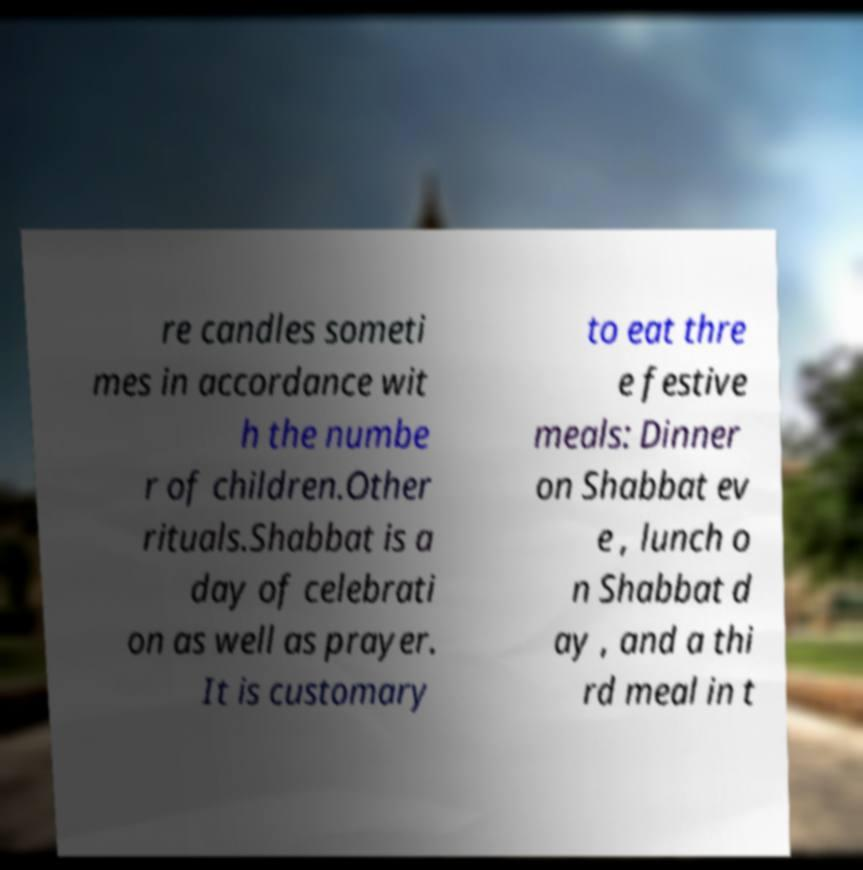Please read and relay the text visible in this image. What does it say? re candles someti mes in accordance wit h the numbe r of children.Other rituals.Shabbat is a day of celebrati on as well as prayer. It is customary to eat thre e festive meals: Dinner on Shabbat ev e , lunch o n Shabbat d ay , and a thi rd meal in t 